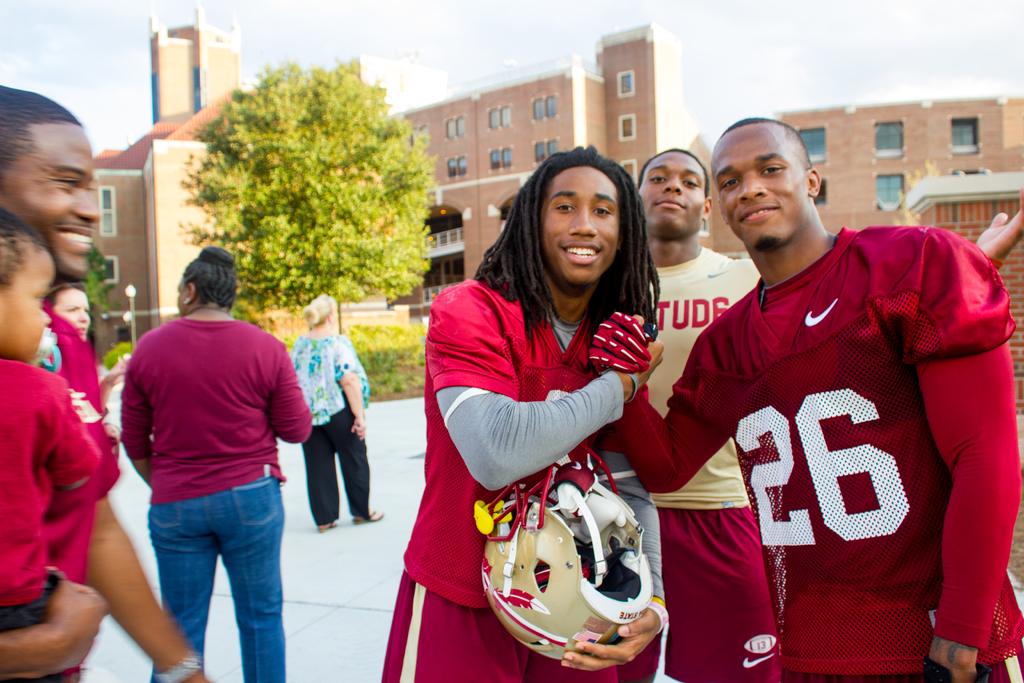What number is on the jersey?
Your response must be concise. 26. What color is the jersey?
Offer a terse response. Answering does not require reading text in the image. 